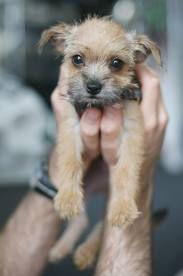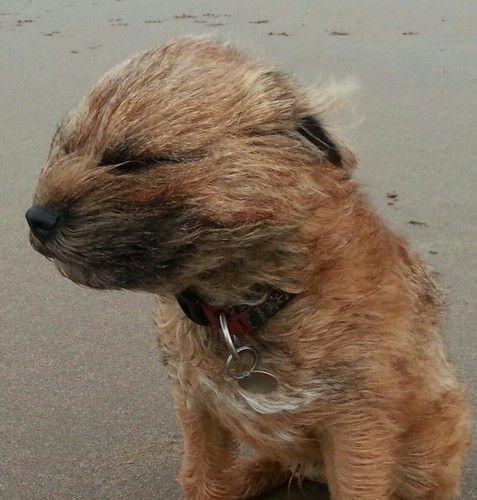The first image is the image on the left, the second image is the image on the right. For the images shown, is this caption "One little dog is wearing a clothing prop." true? Answer yes or no. No. The first image is the image on the left, the second image is the image on the right. Given the left and right images, does the statement "One dog is wearing an article of clothing." hold true? Answer yes or no. No. 